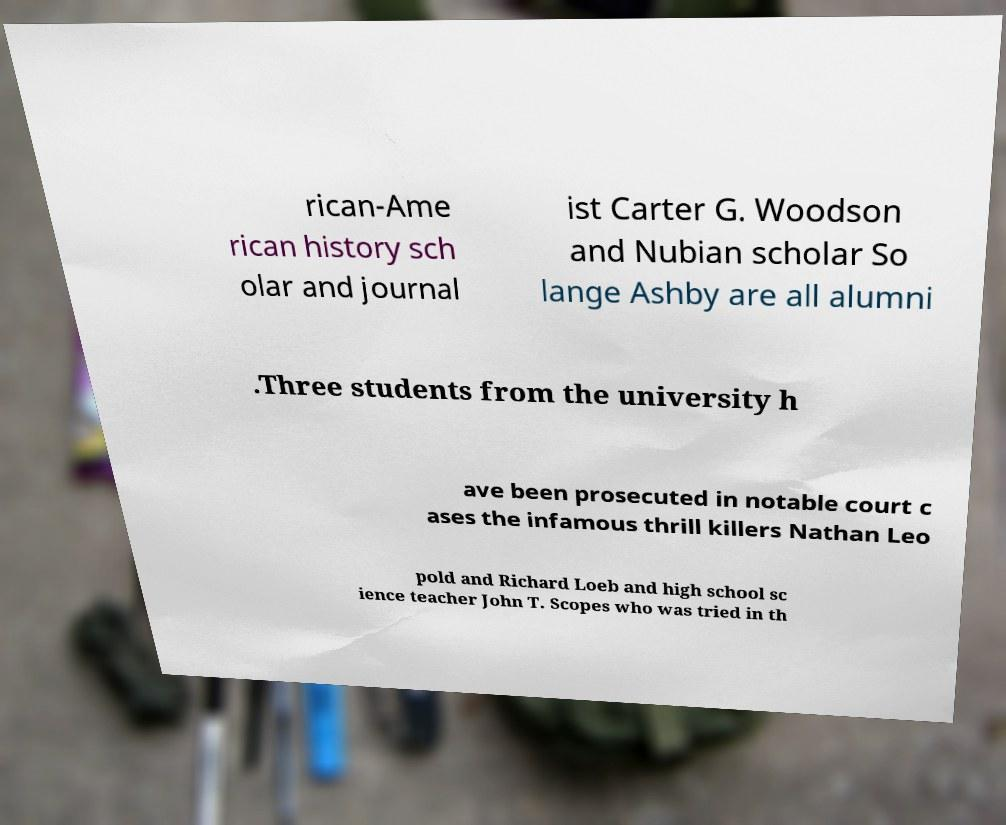Could you assist in decoding the text presented in this image and type it out clearly? rican-Ame rican history sch olar and journal ist Carter G. Woodson and Nubian scholar So lange Ashby are all alumni .Three students from the university h ave been prosecuted in notable court c ases the infamous thrill killers Nathan Leo pold and Richard Loeb and high school sc ience teacher John T. Scopes who was tried in th 